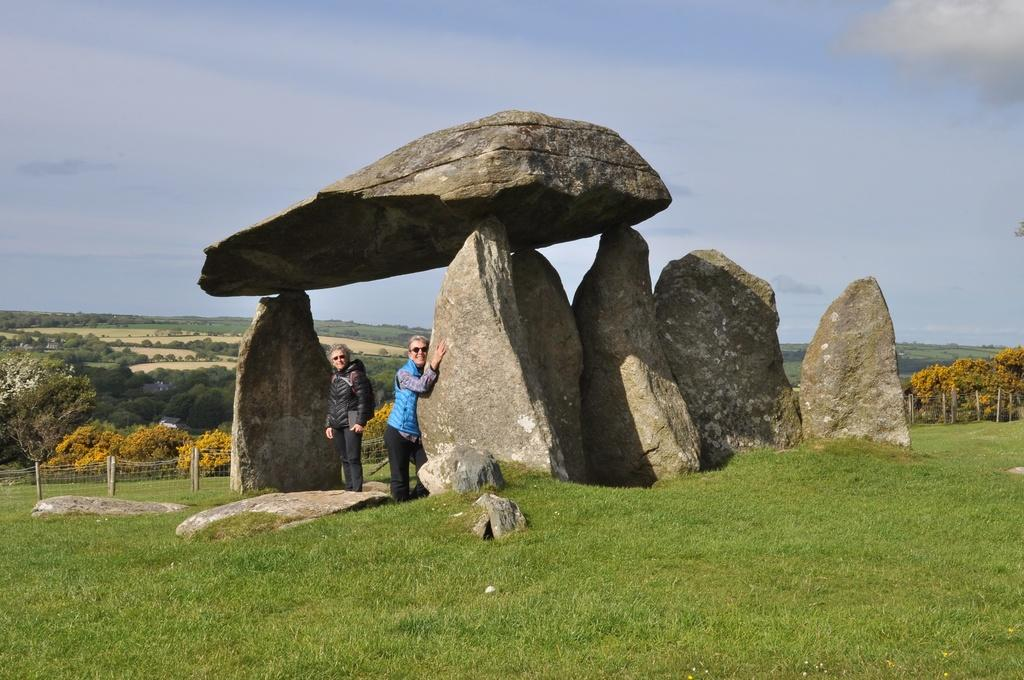What is located in the center of the image? There are rocks in the center of the image. Can you describe the people in the image? There are people in the image. What type of vegetation is at the bottom of the image? There is grass at the bottom of the image. What type of barrier is present in the image? There is a fence in the image. What can be seen in the background of the image? There are trees and the sky visible in the background of the image. Where is the hat located in the image? There is no hat present in the image. Is there a jail visible in the image? There is no jail present in the image. 